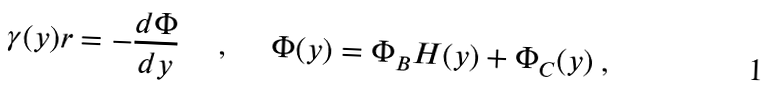<formula> <loc_0><loc_0><loc_500><loc_500>\gamma ( y ) r = - \frac { d \Phi } { d y } \quad \ , \quad \ \Phi ( y ) = \Phi _ { B } H ( y ) + \Phi _ { C } ( y ) \ ,</formula> 